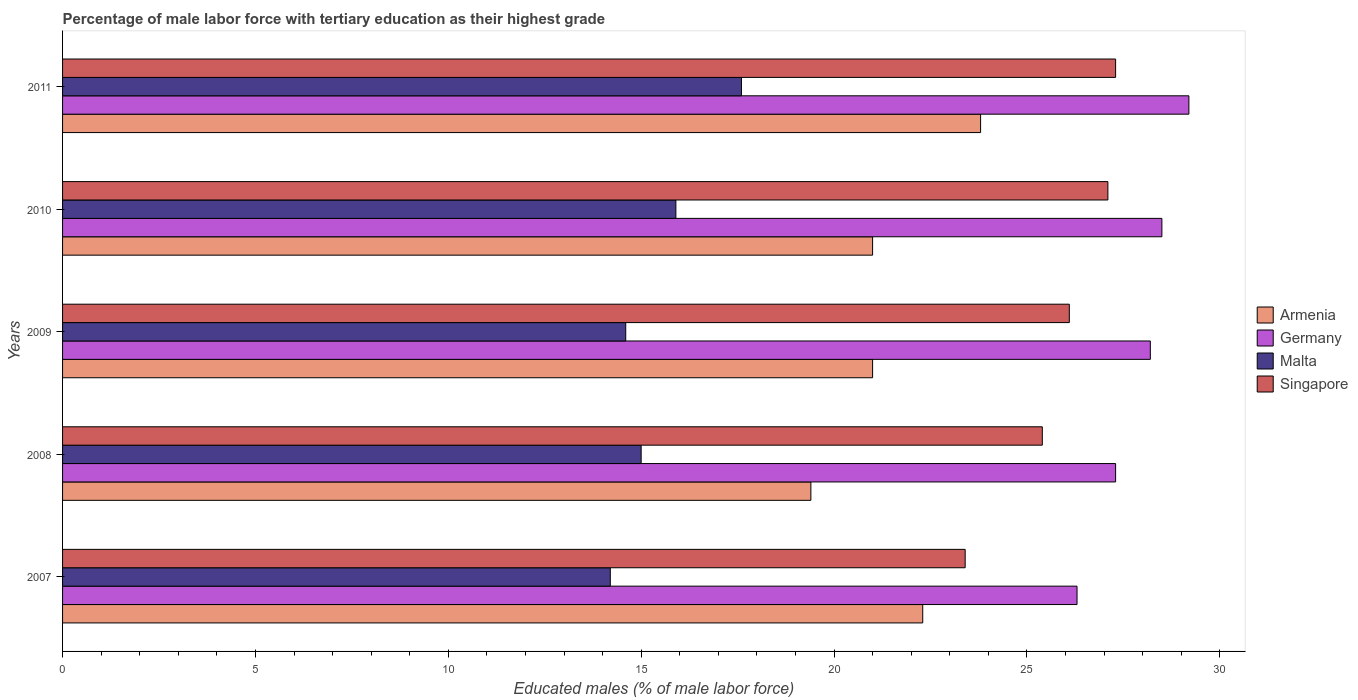How many different coloured bars are there?
Offer a terse response. 4. How many groups of bars are there?
Keep it short and to the point. 5. Are the number of bars per tick equal to the number of legend labels?
Offer a very short reply. Yes. Are the number of bars on each tick of the Y-axis equal?
Provide a short and direct response. Yes. How many bars are there on the 5th tick from the top?
Provide a succinct answer. 4. What is the label of the 5th group of bars from the top?
Give a very brief answer. 2007. In how many cases, is the number of bars for a given year not equal to the number of legend labels?
Make the answer very short. 0. What is the percentage of male labor force with tertiary education in Malta in 2009?
Keep it short and to the point. 14.6. Across all years, what is the maximum percentage of male labor force with tertiary education in Germany?
Keep it short and to the point. 29.2. Across all years, what is the minimum percentage of male labor force with tertiary education in Germany?
Offer a terse response. 26.3. In which year was the percentage of male labor force with tertiary education in Germany minimum?
Ensure brevity in your answer.  2007. What is the total percentage of male labor force with tertiary education in Armenia in the graph?
Offer a very short reply. 107.5. What is the difference between the percentage of male labor force with tertiary education in Malta in 2007 and that in 2008?
Your answer should be very brief. -0.8. What is the difference between the percentage of male labor force with tertiary education in Singapore in 2010 and the percentage of male labor force with tertiary education in Germany in 2011?
Make the answer very short. -2.1. What is the average percentage of male labor force with tertiary education in Armenia per year?
Provide a short and direct response. 21.5. In the year 2007, what is the difference between the percentage of male labor force with tertiary education in Malta and percentage of male labor force with tertiary education in Singapore?
Your answer should be compact. -9.2. What is the ratio of the percentage of male labor force with tertiary education in Armenia in 2008 to that in 2011?
Make the answer very short. 0.82. What is the difference between the highest and the second highest percentage of male labor force with tertiary education in Singapore?
Keep it short and to the point. 0.2. What is the difference between the highest and the lowest percentage of male labor force with tertiary education in Germany?
Provide a short and direct response. 2.9. In how many years, is the percentage of male labor force with tertiary education in Germany greater than the average percentage of male labor force with tertiary education in Germany taken over all years?
Give a very brief answer. 3. What does the 3rd bar from the top in 2010 represents?
Offer a terse response. Germany. What does the 3rd bar from the bottom in 2011 represents?
Your answer should be very brief. Malta. Is it the case that in every year, the sum of the percentage of male labor force with tertiary education in Armenia and percentage of male labor force with tertiary education in Germany is greater than the percentage of male labor force with tertiary education in Singapore?
Offer a very short reply. Yes. How many bars are there?
Ensure brevity in your answer.  20. Are all the bars in the graph horizontal?
Keep it short and to the point. Yes. What is the difference between two consecutive major ticks on the X-axis?
Keep it short and to the point. 5. Are the values on the major ticks of X-axis written in scientific E-notation?
Make the answer very short. No. Does the graph contain grids?
Give a very brief answer. No. Where does the legend appear in the graph?
Your answer should be very brief. Center right. What is the title of the graph?
Provide a succinct answer. Percentage of male labor force with tertiary education as their highest grade. Does "Tajikistan" appear as one of the legend labels in the graph?
Make the answer very short. No. What is the label or title of the X-axis?
Your answer should be compact. Educated males (% of male labor force). What is the Educated males (% of male labor force) of Armenia in 2007?
Offer a very short reply. 22.3. What is the Educated males (% of male labor force) in Germany in 2007?
Your answer should be compact. 26.3. What is the Educated males (% of male labor force) in Malta in 2007?
Offer a terse response. 14.2. What is the Educated males (% of male labor force) in Singapore in 2007?
Give a very brief answer. 23.4. What is the Educated males (% of male labor force) in Armenia in 2008?
Your answer should be compact. 19.4. What is the Educated males (% of male labor force) in Germany in 2008?
Provide a succinct answer. 27.3. What is the Educated males (% of male labor force) of Singapore in 2008?
Offer a very short reply. 25.4. What is the Educated males (% of male labor force) of Armenia in 2009?
Offer a very short reply. 21. What is the Educated males (% of male labor force) in Germany in 2009?
Give a very brief answer. 28.2. What is the Educated males (% of male labor force) of Malta in 2009?
Offer a very short reply. 14.6. What is the Educated males (% of male labor force) in Singapore in 2009?
Ensure brevity in your answer.  26.1. What is the Educated males (% of male labor force) in Armenia in 2010?
Give a very brief answer. 21. What is the Educated males (% of male labor force) of Germany in 2010?
Provide a short and direct response. 28.5. What is the Educated males (% of male labor force) in Malta in 2010?
Provide a short and direct response. 15.9. What is the Educated males (% of male labor force) in Singapore in 2010?
Ensure brevity in your answer.  27.1. What is the Educated males (% of male labor force) in Armenia in 2011?
Your response must be concise. 23.8. What is the Educated males (% of male labor force) of Germany in 2011?
Keep it short and to the point. 29.2. What is the Educated males (% of male labor force) in Malta in 2011?
Your answer should be very brief. 17.6. What is the Educated males (% of male labor force) of Singapore in 2011?
Ensure brevity in your answer.  27.3. Across all years, what is the maximum Educated males (% of male labor force) in Armenia?
Give a very brief answer. 23.8. Across all years, what is the maximum Educated males (% of male labor force) in Germany?
Keep it short and to the point. 29.2. Across all years, what is the maximum Educated males (% of male labor force) in Malta?
Give a very brief answer. 17.6. Across all years, what is the maximum Educated males (% of male labor force) of Singapore?
Your response must be concise. 27.3. Across all years, what is the minimum Educated males (% of male labor force) in Armenia?
Keep it short and to the point. 19.4. Across all years, what is the minimum Educated males (% of male labor force) of Germany?
Provide a short and direct response. 26.3. Across all years, what is the minimum Educated males (% of male labor force) in Malta?
Provide a succinct answer. 14.2. Across all years, what is the minimum Educated males (% of male labor force) of Singapore?
Your response must be concise. 23.4. What is the total Educated males (% of male labor force) of Armenia in the graph?
Ensure brevity in your answer.  107.5. What is the total Educated males (% of male labor force) of Germany in the graph?
Offer a terse response. 139.5. What is the total Educated males (% of male labor force) in Malta in the graph?
Your response must be concise. 77.3. What is the total Educated males (% of male labor force) of Singapore in the graph?
Give a very brief answer. 129.3. What is the difference between the Educated males (% of male labor force) in Singapore in 2007 and that in 2008?
Ensure brevity in your answer.  -2. What is the difference between the Educated males (% of male labor force) of Armenia in 2007 and that in 2009?
Ensure brevity in your answer.  1.3. What is the difference between the Educated males (% of male labor force) of Singapore in 2007 and that in 2009?
Provide a succinct answer. -2.7. What is the difference between the Educated males (% of male labor force) in Armenia in 2007 and that in 2010?
Give a very brief answer. 1.3. What is the difference between the Educated males (% of male labor force) in Malta in 2007 and that in 2010?
Keep it short and to the point. -1.7. What is the difference between the Educated males (% of male labor force) of Germany in 2008 and that in 2009?
Your answer should be compact. -0.9. What is the difference between the Educated males (% of male labor force) of Singapore in 2008 and that in 2009?
Your answer should be very brief. -0.7. What is the difference between the Educated males (% of male labor force) of Malta in 2008 and that in 2010?
Your answer should be compact. -0.9. What is the difference between the Educated males (% of male labor force) of Armenia in 2008 and that in 2011?
Offer a terse response. -4.4. What is the difference between the Educated males (% of male labor force) in Malta in 2008 and that in 2011?
Your answer should be compact. -2.6. What is the difference between the Educated males (% of male labor force) of Singapore in 2008 and that in 2011?
Keep it short and to the point. -1.9. What is the difference between the Educated males (% of male labor force) in Armenia in 2009 and that in 2010?
Keep it short and to the point. 0. What is the difference between the Educated males (% of male labor force) in Malta in 2009 and that in 2011?
Ensure brevity in your answer.  -3. What is the difference between the Educated males (% of male labor force) in Singapore in 2009 and that in 2011?
Provide a succinct answer. -1.2. What is the difference between the Educated males (% of male labor force) of Armenia in 2010 and that in 2011?
Offer a very short reply. -2.8. What is the difference between the Educated males (% of male labor force) of Armenia in 2007 and the Educated males (% of male labor force) of Germany in 2008?
Your response must be concise. -5. What is the difference between the Educated males (% of male labor force) of Armenia in 2007 and the Educated males (% of male labor force) of Malta in 2008?
Provide a short and direct response. 7.3. What is the difference between the Educated males (% of male labor force) of Armenia in 2007 and the Educated males (% of male labor force) of Singapore in 2008?
Provide a short and direct response. -3.1. What is the difference between the Educated males (% of male labor force) in Malta in 2007 and the Educated males (% of male labor force) in Singapore in 2008?
Provide a succinct answer. -11.2. What is the difference between the Educated males (% of male labor force) in Armenia in 2007 and the Educated males (% of male labor force) in Germany in 2009?
Keep it short and to the point. -5.9. What is the difference between the Educated males (% of male labor force) in Germany in 2007 and the Educated males (% of male labor force) in Malta in 2009?
Make the answer very short. 11.7. What is the difference between the Educated males (% of male labor force) of Germany in 2007 and the Educated males (% of male labor force) of Singapore in 2009?
Give a very brief answer. 0.2. What is the difference between the Educated males (% of male labor force) in Malta in 2007 and the Educated males (% of male labor force) in Singapore in 2009?
Your answer should be very brief. -11.9. What is the difference between the Educated males (% of male labor force) of Armenia in 2007 and the Educated males (% of male labor force) of Malta in 2010?
Ensure brevity in your answer.  6.4. What is the difference between the Educated males (% of male labor force) of Germany in 2007 and the Educated males (% of male labor force) of Singapore in 2010?
Your answer should be compact. -0.8. What is the difference between the Educated males (% of male labor force) in Malta in 2007 and the Educated males (% of male labor force) in Singapore in 2010?
Your answer should be very brief. -12.9. What is the difference between the Educated males (% of male labor force) of Armenia in 2007 and the Educated males (% of male labor force) of Germany in 2011?
Ensure brevity in your answer.  -6.9. What is the difference between the Educated males (% of male labor force) of Armenia in 2007 and the Educated males (% of male labor force) of Singapore in 2011?
Your response must be concise. -5. What is the difference between the Educated males (% of male labor force) in Germany in 2007 and the Educated males (% of male labor force) in Malta in 2011?
Your answer should be compact. 8.7. What is the difference between the Educated males (% of male labor force) of Armenia in 2008 and the Educated males (% of male labor force) of Germany in 2009?
Offer a very short reply. -8.8. What is the difference between the Educated males (% of male labor force) in Armenia in 2008 and the Educated males (% of male labor force) in Malta in 2009?
Provide a short and direct response. 4.8. What is the difference between the Educated males (% of male labor force) in Armenia in 2008 and the Educated males (% of male labor force) in Singapore in 2009?
Ensure brevity in your answer.  -6.7. What is the difference between the Educated males (% of male labor force) in Malta in 2008 and the Educated males (% of male labor force) in Singapore in 2009?
Give a very brief answer. -11.1. What is the difference between the Educated males (% of male labor force) in Armenia in 2008 and the Educated males (% of male labor force) in Malta in 2010?
Your answer should be very brief. 3.5. What is the difference between the Educated males (% of male labor force) of Armenia in 2008 and the Educated males (% of male labor force) of Singapore in 2010?
Your response must be concise. -7.7. What is the difference between the Educated males (% of male labor force) of Germany in 2008 and the Educated males (% of male labor force) of Malta in 2010?
Ensure brevity in your answer.  11.4. What is the difference between the Educated males (% of male labor force) in Armenia in 2008 and the Educated males (% of male labor force) in Singapore in 2011?
Provide a short and direct response. -7.9. What is the difference between the Educated males (% of male labor force) in Germany in 2008 and the Educated males (% of male labor force) in Malta in 2011?
Make the answer very short. 9.7. What is the difference between the Educated males (% of male labor force) in Germany in 2008 and the Educated males (% of male labor force) in Singapore in 2011?
Keep it short and to the point. 0. What is the difference between the Educated males (% of male labor force) in Malta in 2008 and the Educated males (% of male labor force) in Singapore in 2011?
Ensure brevity in your answer.  -12.3. What is the difference between the Educated males (% of male labor force) of Armenia in 2009 and the Educated males (% of male labor force) of Malta in 2010?
Provide a succinct answer. 5.1. What is the difference between the Educated males (% of male labor force) of Armenia in 2009 and the Educated males (% of male labor force) of Singapore in 2010?
Your response must be concise. -6.1. What is the difference between the Educated males (% of male labor force) in Germany in 2009 and the Educated males (% of male labor force) in Singapore in 2010?
Offer a terse response. 1.1. What is the difference between the Educated males (% of male labor force) in Malta in 2009 and the Educated males (% of male labor force) in Singapore in 2010?
Offer a terse response. -12.5. What is the difference between the Educated males (% of male labor force) of Armenia in 2009 and the Educated males (% of male labor force) of Germany in 2011?
Provide a short and direct response. -8.2. What is the difference between the Educated males (% of male labor force) of Armenia in 2009 and the Educated males (% of male labor force) of Malta in 2011?
Make the answer very short. 3.4. What is the difference between the Educated males (% of male labor force) in Armenia in 2009 and the Educated males (% of male labor force) in Singapore in 2011?
Make the answer very short. -6.3. What is the difference between the Educated males (% of male labor force) of Germany in 2009 and the Educated males (% of male labor force) of Malta in 2011?
Give a very brief answer. 10.6. What is the difference between the Educated males (% of male labor force) of Armenia in 2010 and the Educated males (% of male labor force) of Malta in 2011?
Your response must be concise. 3.4. What is the difference between the Educated males (% of male labor force) of Armenia in 2010 and the Educated males (% of male labor force) of Singapore in 2011?
Your answer should be very brief. -6.3. What is the difference between the Educated males (% of male labor force) in Germany in 2010 and the Educated males (% of male labor force) in Malta in 2011?
Give a very brief answer. 10.9. What is the difference between the Educated males (% of male labor force) of Malta in 2010 and the Educated males (% of male labor force) of Singapore in 2011?
Offer a very short reply. -11.4. What is the average Educated males (% of male labor force) in Germany per year?
Provide a short and direct response. 27.9. What is the average Educated males (% of male labor force) of Malta per year?
Provide a short and direct response. 15.46. What is the average Educated males (% of male labor force) of Singapore per year?
Keep it short and to the point. 25.86. In the year 2007, what is the difference between the Educated males (% of male labor force) in Armenia and Educated males (% of male labor force) in Singapore?
Make the answer very short. -1.1. In the year 2007, what is the difference between the Educated males (% of male labor force) in Germany and Educated males (% of male labor force) in Malta?
Make the answer very short. 12.1. In the year 2008, what is the difference between the Educated males (% of male labor force) of Armenia and Educated males (% of male labor force) of Germany?
Provide a short and direct response. -7.9. In the year 2008, what is the difference between the Educated males (% of male labor force) of Armenia and Educated males (% of male labor force) of Malta?
Offer a terse response. 4.4. In the year 2008, what is the difference between the Educated males (% of male labor force) in Armenia and Educated males (% of male labor force) in Singapore?
Provide a succinct answer. -6. In the year 2008, what is the difference between the Educated males (% of male labor force) in Germany and Educated males (% of male labor force) in Singapore?
Your response must be concise. 1.9. In the year 2009, what is the difference between the Educated males (% of male labor force) in Armenia and Educated males (% of male labor force) in Germany?
Provide a short and direct response. -7.2. In the year 2009, what is the difference between the Educated males (% of male labor force) in Armenia and Educated males (% of male labor force) in Malta?
Keep it short and to the point. 6.4. In the year 2009, what is the difference between the Educated males (% of male labor force) in Germany and Educated males (% of male labor force) in Singapore?
Provide a short and direct response. 2.1. In the year 2010, what is the difference between the Educated males (% of male labor force) in Armenia and Educated males (% of male labor force) in Germany?
Provide a succinct answer. -7.5. In the year 2010, what is the difference between the Educated males (% of male labor force) of Armenia and Educated males (% of male labor force) of Malta?
Your answer should be very brief. 5.1. In the year 2011, what is the difference between the Educated males (% of male labor force) in Armenia and Educated males (% of male labor force) in Germany?
Provide a succinct answer. -5.4. In the year 2011, what is the difference between the Educated males (% of male labor force) in Armenia and Educated males (% of male labor force) in Singapore?
Keep it short and to the point. -3.5. In the year 2011, what is the difference between the Educated males (% of male labor force) in Germany and Educated males (% of male labor force) in Malta?
Provide a succinct answer. 11.6. In the year 2011, what is the difference between the Educated males (% of male labor force) in Germany and Educated males (% of male labor force) in Singapore?
Make the answer very short. 1.9. What is the ratio of the Educated males (% of male labor force) of Armenia in 2007 to that in 2008?
Give a very brief answer. 1.15. What is the ratio of the Educated males (% of male labor force) in Germany in 2007 to that in 2008?
Keep it short and to the point. 0.96. What is the ratio of the Educated males (% of male labor force) of Malta in 2007 to that in 2008?
Your answer should be very brief. 0.95. What is the ratio of the Educated males (% of male labor force) in Singapore in 2007 to that in 2008?
Provide a succinct answer. 0.92. What is the ratio of the Educated males (% of male labor force) of Armenia in 2007 to that in 2009?
Offer a very short reply. 1.06. What is the ratio of the Educated males (% of male labor force) in Germany in 2007 to that in 2009?
Your response must be concise. 0.93. What is the ratio of the Educated males (% of male labor force) in Malta in 2007 to that in 2009?
Offer a very short reply. 0.97. What is the ratio of the Educated males (% of male labor force) in Singapore in 2007 to that in 2009?
Provide a short and direct response. 0.9. What is the ratio of the Educated males (% of male labor force) of Armenia in 2007 to that in 2010?
Ensure brevity in your answer.  1.06. What is the ratio of the Educated males (% of male labor force) in Germany in 2007 to that in 2010?
Keep it short and to the point. 0.92. What is the ratio of the Educated males (% of male labor force) in Malta in 2007 to that in 2010?
Your response must be concise. 0.89. What is the ratio of the Educated males (% of male labor force) of Singapore in 2007 to that in 2010?
Your answer should be very brief. 0.86. What is the ratio of the Educated males (% of male labor force) of Armenia in 2007 to that in 2011?
Provide a short and direct response. 0.94. What is the ratio of the Educated males (% of male labor force) in Germany in 2007 to that in 2011?
Keep it short and to the point. 0.9. What is the ratio of the Educated males (% of male labor force) in Malta in 2007 to that in 2011?
Offer a terse response. 0.81. What is the ratio of the Educated males (% of male labor force) of Armenia in 2008 to that in 2009?
Your response must be concise. 0.92. What is the ratio of the Educated males (% of male labor force) of Germany in 2008 to that in 2009?
Your answer should be compact. 0.97. What is the ratio of the Educated males (% of male labor force) in Malta in 2008 to that in 2009?
Provide a short and direct response. 1.03. What is the ratio of the Educated males (% of male labor force) of Singapore in 2008 to that in 2009?
Provide a succinct answer. 0.97. What is the ratio of the Educated males (% of male labor force) of Armenia in 2008 to that in 2010?
Make the answer very short. 0.92. What is the ratio of the Educated males (% of male labor force) of Germany in 2008 to that in 2010?
Your answer should be compact. 0.96. What is the ratio of the Educated males (% of male labor force) in Malta in 2008 to that in 2010?
Offer a terse response. 0.94. What is the ratio of the Educated males (% of male labor force) of Singapore in 2008 to that in 2010?
Your answer should be very brief. 0.94. What is the ratio of the Educated males (% of male labor force) in Armenia in 2008 to that in 2011?
Your response must be concise. 0.82. What is the ratio of the Educated males (% of male labor force) of Germany in 2008 to that in 2011?
Keep it short and to the point. 0.93. What is the ratio of the Educated males (% of male labor force) in Malta in 2008 to that in 2011?
Give a very brief answer. 0.85. What is the ratio of the Educated males (% of male labor force) of Singapore in 2008 to that in 2011?
Your answer should be very brief. 0.93. What is the ratio of the Educated males (% of male labor force) in Armenia in 2009 to that in 2010?
Give a very brief answer. 1. What is the ratio of the Educated males (% of male labor force) of Germany in 2009 to that in 2010?
Your response must be concise. 0.99. What is the ratio of the Educated males (% of male labor force) in Malta in 2009 to that in 2010?
Give a very brief answer. 0.92. What is the ratio of the Educated males (% of male labor force) of Singapore in 2009 to that in 2010?
Offer a terse response. 0.96. What is the ratio of the Educated males (% of male labor force) of Armenia in 2009 to that in 2011?
Provide a succinct answer. 0.88. What is the ratio of the Educated males (% of male labor force) in Germany in 2009 to that in 2011?
Your response must be concise. 0.97. What is the ratio of the Educated males (% of male labor force) of Malta in 2009 to that in 2011?
Offer a terse response. 0.83. What is the ratio of the Educated males (% of male labor force) in Singapore in 2009 to that in 2011?
Ensure brevity in your answer.  0.96. What is the ratio of the Educated males (% of male labor force) in Armenia in 2010 to that in 2011?
Your response must be concise. 0.88. What is the ratio of the Educated males (% of male labor force) of Germany in 2010 to that in 2011?
Ensure brevity in your answer.  0.98. What is the ratio of the Educated males (% of male labor force) in Malta in 2010 to that in 2011?
Provide a short and direct response. 0.9. What is the ratio of the Educated males (% of male labor force) of Singapore in 2010 to that in 2011?
Give a very brief answer. 0.99. What is the difference between the highest and the second highest Educated males (% of male labor force) of Armenia?
Offer a very short reply. 1.5. What is the difference between the highest and the second highest Educated males (% of male labor force) in Singapore?
Make the answer very short. 0.2. What is the difference between the highest and the lowest Educated males (% of male labor force) in Armenia?
Offer a very short reply. 4.4. What is the difference between the highest and the lowest Educated males (% of male labor force) in Germany?
Ensure brevity in your answer.  2.9. 